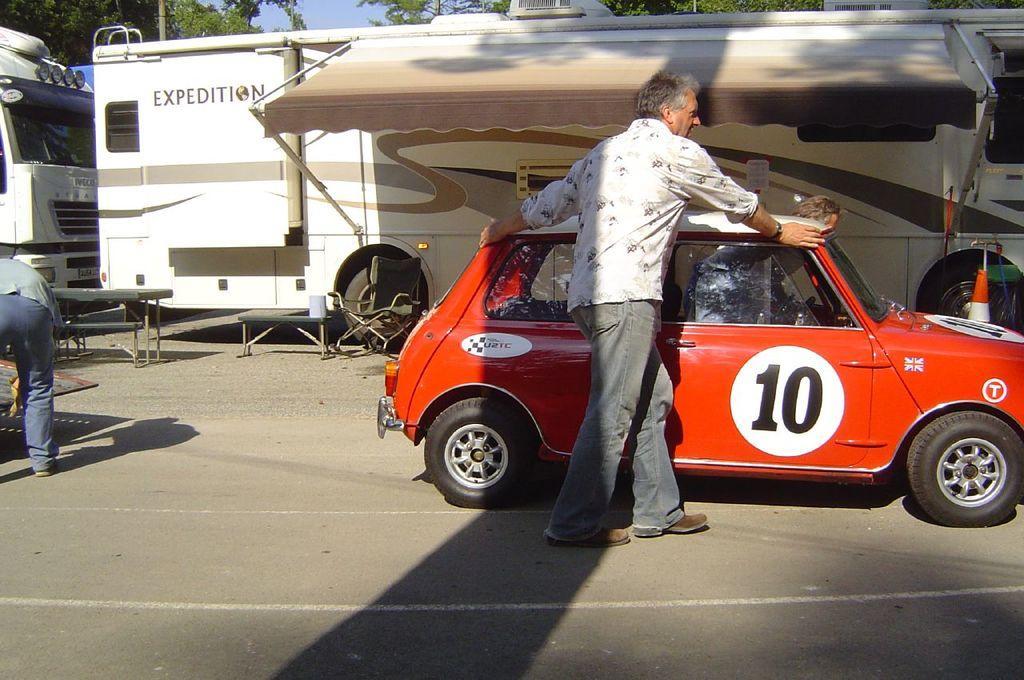Describe this image in one or two sentences. In this image, we can see a person is walking on the road and holding a car. Background we can see few vehicles, poles, benches. Here we can see few people. Top of the image, we can see trees, poles and sky. 